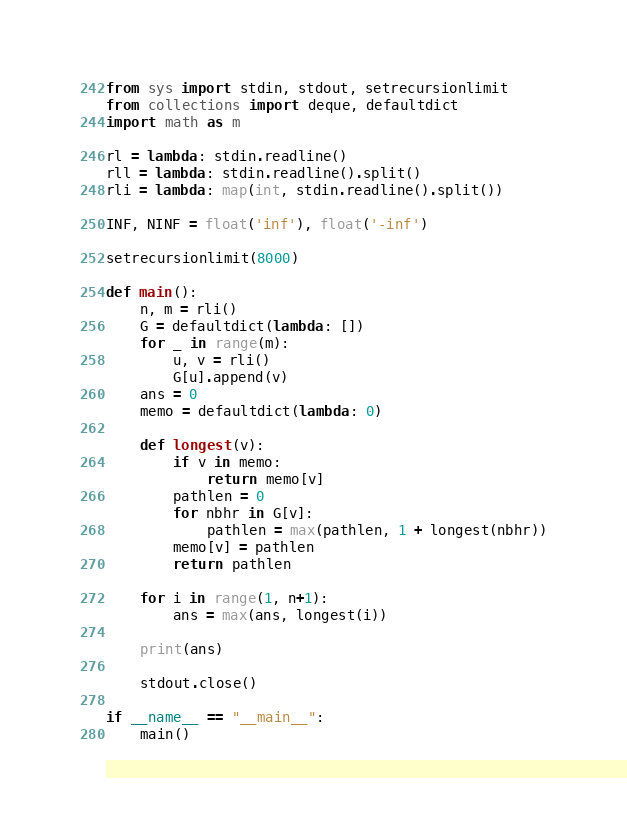<code> <loc_0><loc_0><loc_500><loc_500><_Python_>from sys import stdin, stdout, setrecursionlimit
from collections import deque, defaultdict
import math as m

rl = lambda: stdin.readline()
rll = lambda: stdin.readline().split()
rli = lambda: map(int, stdin.readline().split())

INF, NINF = float('inf'), float('-inf')

setrecursionlimit(8000)

def main():
	n, m = rli()
	G = defaultdict(lambda: [])
	for _ in range(m):
		u, v = rli()
		G[u].append(v)
	ans = 0
	memo = defaultdict(lambda: 0)

	def longest(v):
		if v in memo:
			return memo[v]
		pathlen = 0
		for nbhr in G[v]:
			pathlen = max(pathlen, 1 + longest(nbhr))
		memo[v] = pathlen
		return pathlen

	for i in range(1, n+1):
		ans = max(ans, longest(i))

	print(ans)

	stdout.close()

if __name__ == "__main__":
	main()</code> 